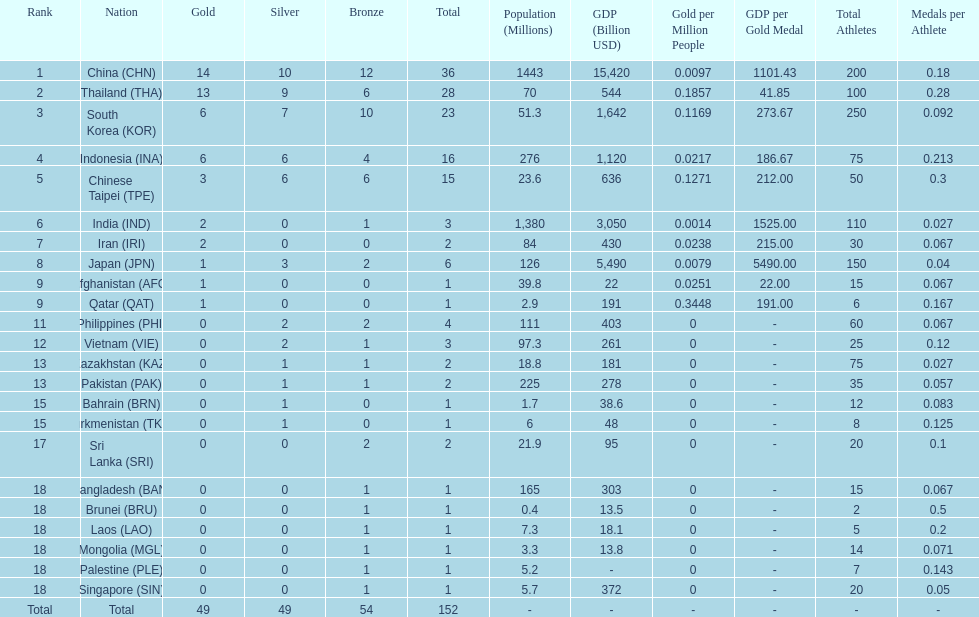Did the philippines or kazakhstan have a higher number of total medals? Philippines. 